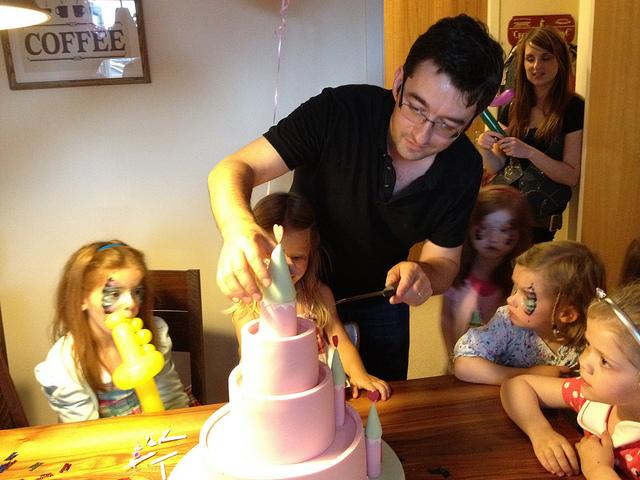Where was the castle themed birthday cake most likely created?

Choices:
A) restaurant
B) food bank
C) home kitchen
D) bakery bakery 